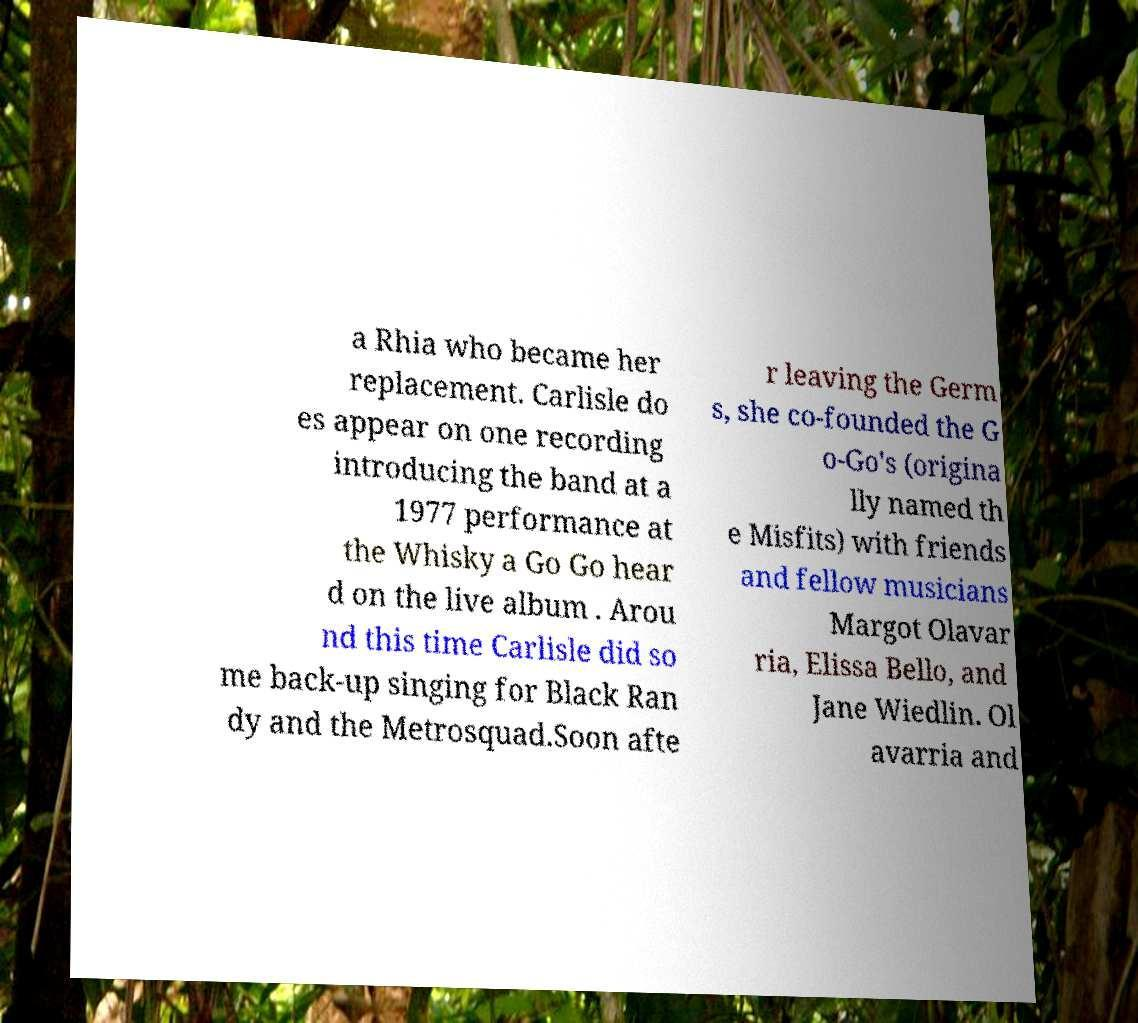What messages or text are displayed in this image? I need them in a readable, typed format. a Rhia who became her replacement. Carlisle do es appear on one recording introducing the band at a 1977 performance at the Whisky a Go Go hear d on the live album . Arou nd this time Carlisle did so me back-up singing for Black Ran dy and the Metrosquad.Soon afte r leaving the Germ s, she co-founded the G o-Go's (origina lly named th e Misfits) with friends and fellow musicians Margot Olavar ria, Elissa Bello, and Jane Wiedlin. Ol avarria and 